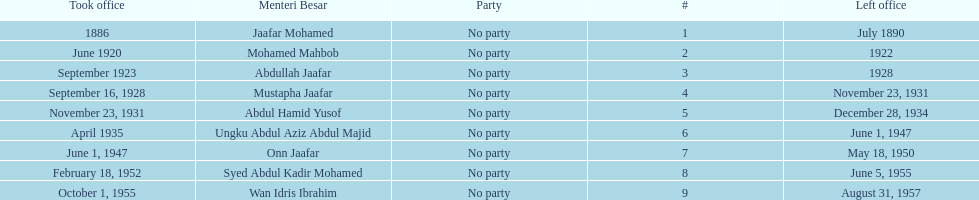Who is listed below onn jaafar? Syed Abdul Kadir Mohamed. 